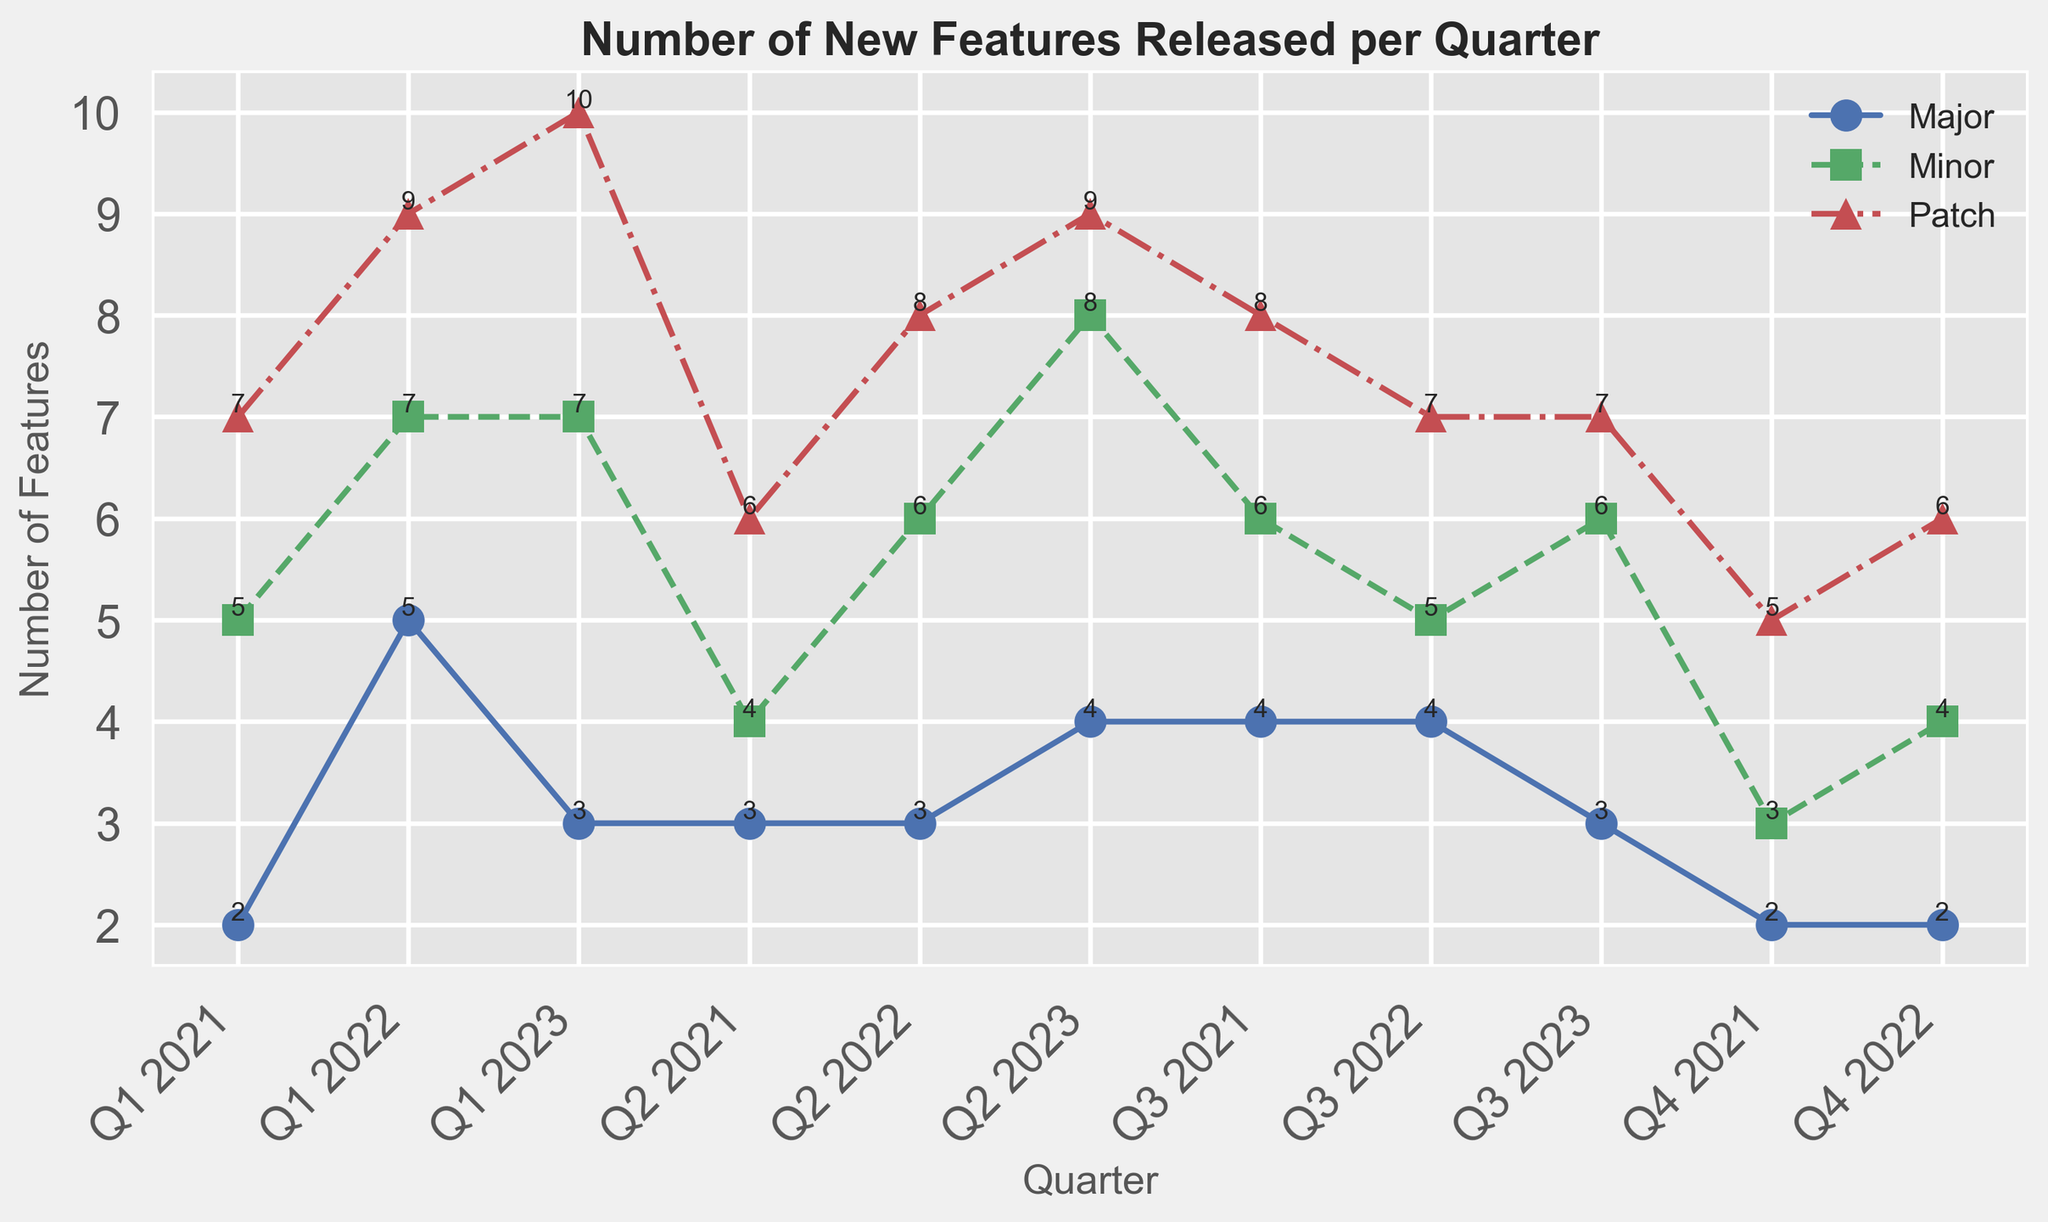What's the total number of features (all types) released in Q1 2023? Sum the number of Major, Minor, and Patch features for Q1 2023: Major(3) + Minor(7) + Patch(10) = 20
Answer: 20 How does the number of Major features in Q2 2023 compare to Q4 2022? In Q2 2023, Major features are 4. In Q4 2022, Major features are 2. Therefore, Q2 2023 has 2 more Major features than Q4 2022.
Answer: Q2 2023 has 2 more Which quarter had the highest number of Patch features, and what was the number? By looking at the graph, the highest number of Patch features is in Q1 2023, which is 10.
Answer: Q1 2023, 10 Did the number of Minor features released increase or decrease from Q1 2022 to Q2 2022, and by how much? The number of Minor features in Q1 2022 is 7, and in Q2 2022 is 6. The number decreased by 1.
Answer: Decrease, by 1 Identify the trend for Major features from Q1 2021 to Q3 2023. The trend for Major features shows fluctuations: 2 (Q1 2021) -> 3 (Q2 2021) -> 4 (Q3 2021) -> 2 (Q4 2021) -> 5 (Q1 2022) -> 3 (Q2 2022) -> 4 (Q3 2022) -> 2 (Q4 2022) -> 3 (Q1 2023) -> 4 (Q2 2023) -> 3 (Q3 2023). It increases, decreases, and fluctuates irregularly.
Answer: Fluctuating What was the average number of Minor features released per quarter in 2021? Sum the Minor features for each quarter in 2021 and divide by 4: (5 + 4 + 6 + 3) / 4 = 18 / 4 = 4.5
Answer: 4.5 During which quarter and year did the total number of features (Major, Minor, Patch) reach its peak, and what was the total number? The total number of features is the highest in Q2 2023 with: Major(4) + Minor(8) + Patch(9) = 21
Answer: Q2 2023, 21 What was the percentage increase in Patch features from Q4 2021 to Q1 2022? Patch features in Q4 2021 are 5, and in Q1 2022 are 9. The increase is (9 - 5) / 5 * 100% = 80%
Answer: 80% Compare the frequency of Minor feature releases between 2021 and 2022. Count the Minor features: 2021 has (5 + 4 + 6 + 3) = 18 features, 2022 has (7 + 6 + 5 + 4) = 22 features. Therefore, 2022 had 4 more Minor features than 2021.
Answer: 2022 had 4 more Which feature type was released the most in Q2 2022? In Q2 2022, Patch was the most released feature type with 8 features.
Answer: Patch 